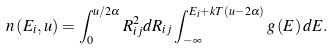Convert formula to latex. <formula><loc_0><loc_0><loc_500><loc_500>n \left ( E _ { i } , u \right ) = \int _ { 0 } ^ { u / { 2 \alpha } } R _ { i j } ^ { 2 } d R _ { i j } \int _ { - \infty } ^ { E _ { i } + k T \left ( u - 2 \alpha \right ) } g \left ( E \right ) d E .</formula> 